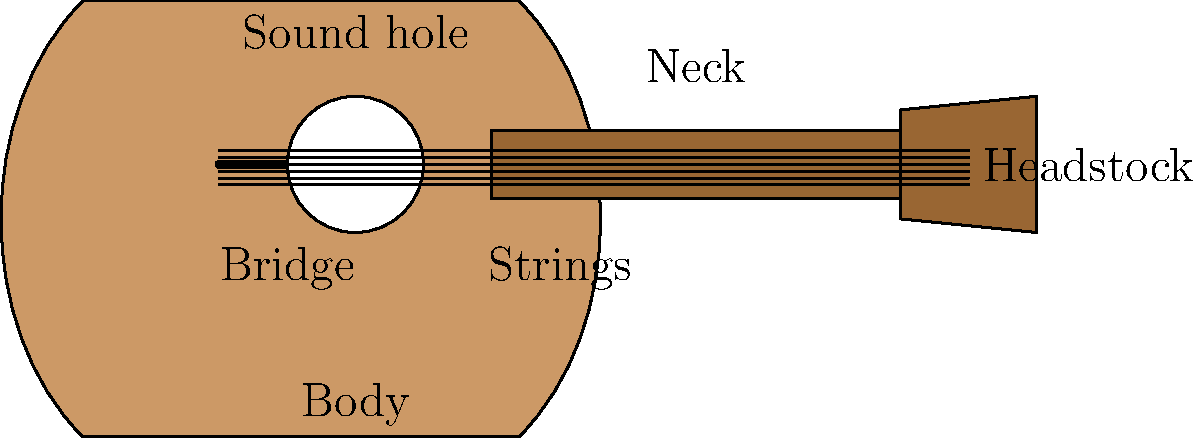As a country music enthusiast and guitar player, you're familiar with the parts of an acoustic guitar. In the diagram above, which part of the guitar is responsible for amplifying the sound produced by the vibrating strings? To answer this question, let's break down the function of each part of the acoustic guitar:

1. Body: The large, hollow part of the guitar that resonates and amplifies the sound.
2. Neck: The long, narrow part where the fretboard is located.
3. Headstock: The top part of the guitar where the tuning pegs are located.
4. Bridge: The part that anchors the strings to the body and transfers their vibrations.
5. Sound hole: The circular opening on the body that helps project the sound.
6. Strings: The taut wires that vibrate to produce sound when plucked or strummed.

The key to amplifying the sound in an acoustic guitar is the body. When the strings vibrate, their energy is transferred to the bridge, which then causes the guitar's body to vibrate. The large surface area of the body acts as a natural amplifier, increasing the volume and richness of the sound.

The sound hole also plays a role in projecting the sound outward, but it's primarily the body that's responsible for amplification.

Therefore, the part of the guitar responsible for amplifying the sound produced by the vibrating strings is the body.
Answer: Body 